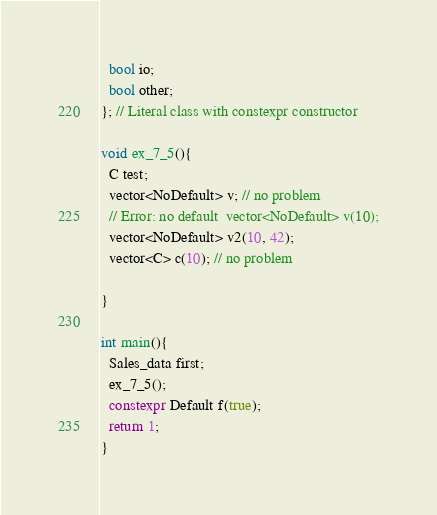<code> <loc_0><loc_0><loc_500><loc_500><_C++_>  bool io;
  bool other;
}; // Literal class with constexpr constructor
  
void ex_7_5(){
  C test;
  vector<NoDefault> v; // no problem
  // Error: no default  vector<NoDefault> v(10);
  vector<NoDefault> v2(10, 42);
  vector<C> c(10); // no problem
  
}

int main(){
  Sales_data first;
  ex_7_5();
  constexpr Default f(true);
  return 1;
}
</code> 